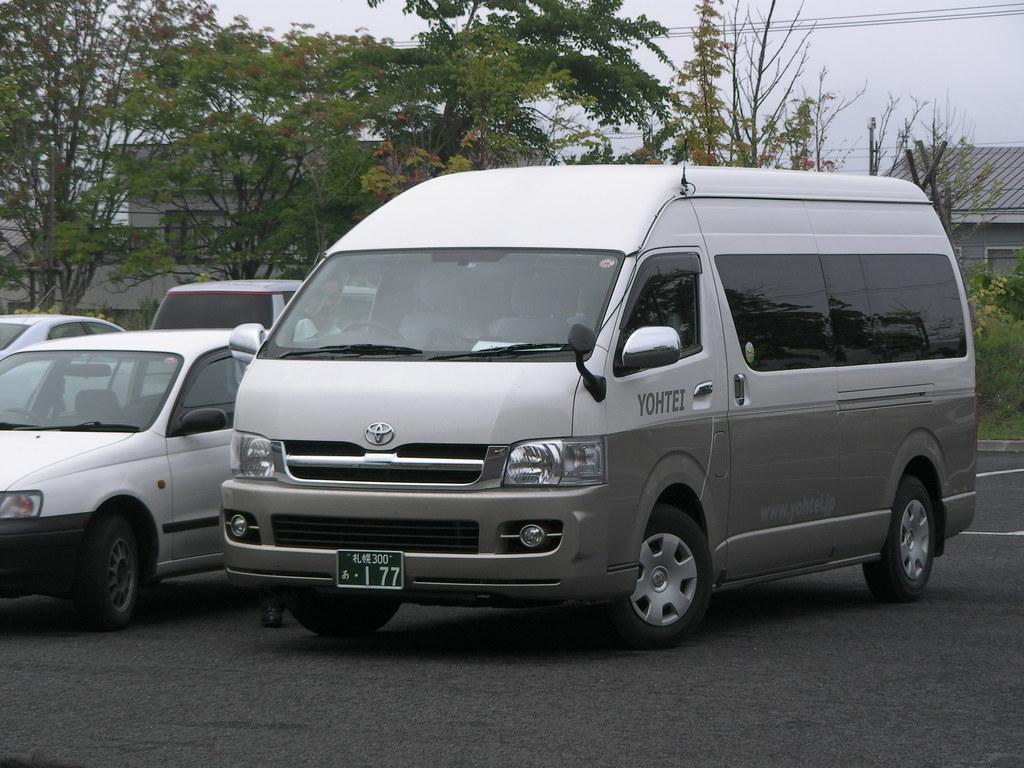What brand of bus is this?
Offer a very short reply. Toyota. What is the last number on the tag?
Ensure brevity in your answer.  7. 